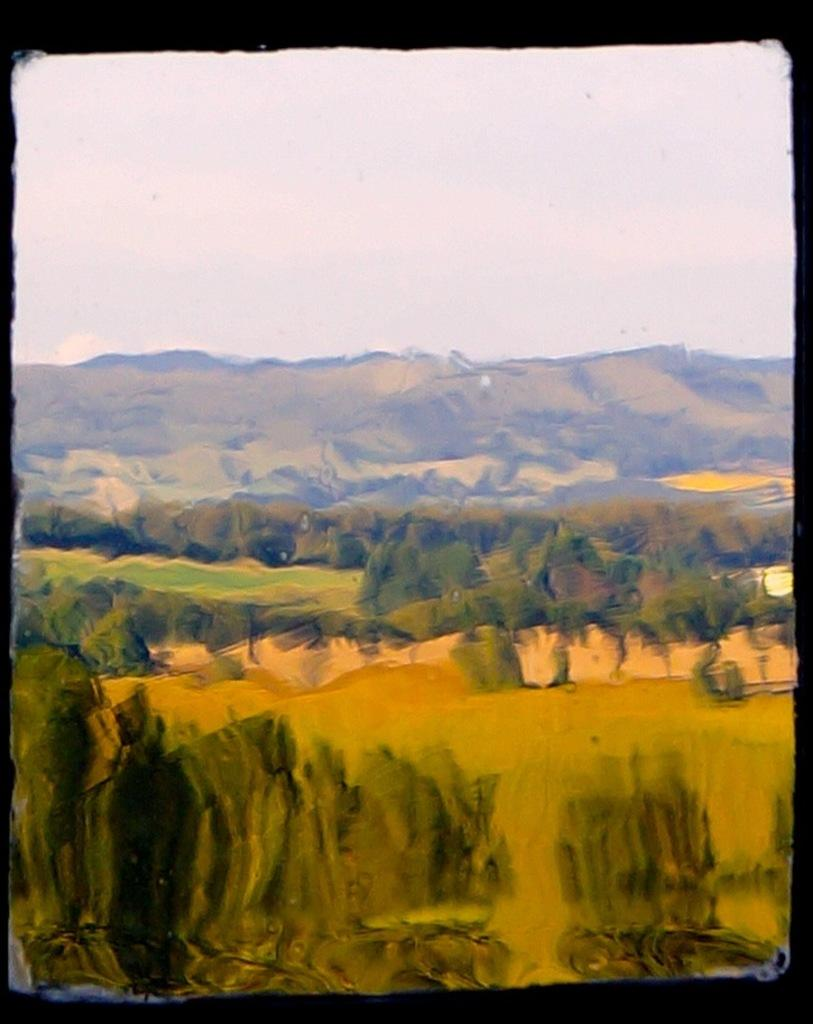What type of landform is present in the image? There is a hill in the image. What else can be seen in the image besides the hill? The sky is visible in the image. How many cups of tea does the yak have in the image? There is no yak present in the image, and therefore no cups of tea can be counted. 